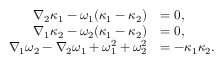Convert formula to latex. <formula><loc_0><loc_0><loc_500><loc_500>\begin{array} { r l } { \nabla _ { 2 } \kappa _ { 1 } - \omega _ { 1 } ( \kappa _ { 1 } - \kappa _ { 2 } ) } & { = 0 , } \\ { \nabla _ { 1 } \kappa _ { 2 } - \omega _ { 2 } ( \kappa _ { 1 } - \kappa _ { 2 } ) } & { = 0 , } \\ { \nabla _ { 1 } \omega _ { 2 } - \nabla _ { 2 } \omega _ { 1 } + \omega _ { 1 } ^ { 2 } + \omega _ { 2 } ^ { 2 } } & { = - \kappa _ { 1 } \kappa _ { 2 } . } \end{array}</formula> 